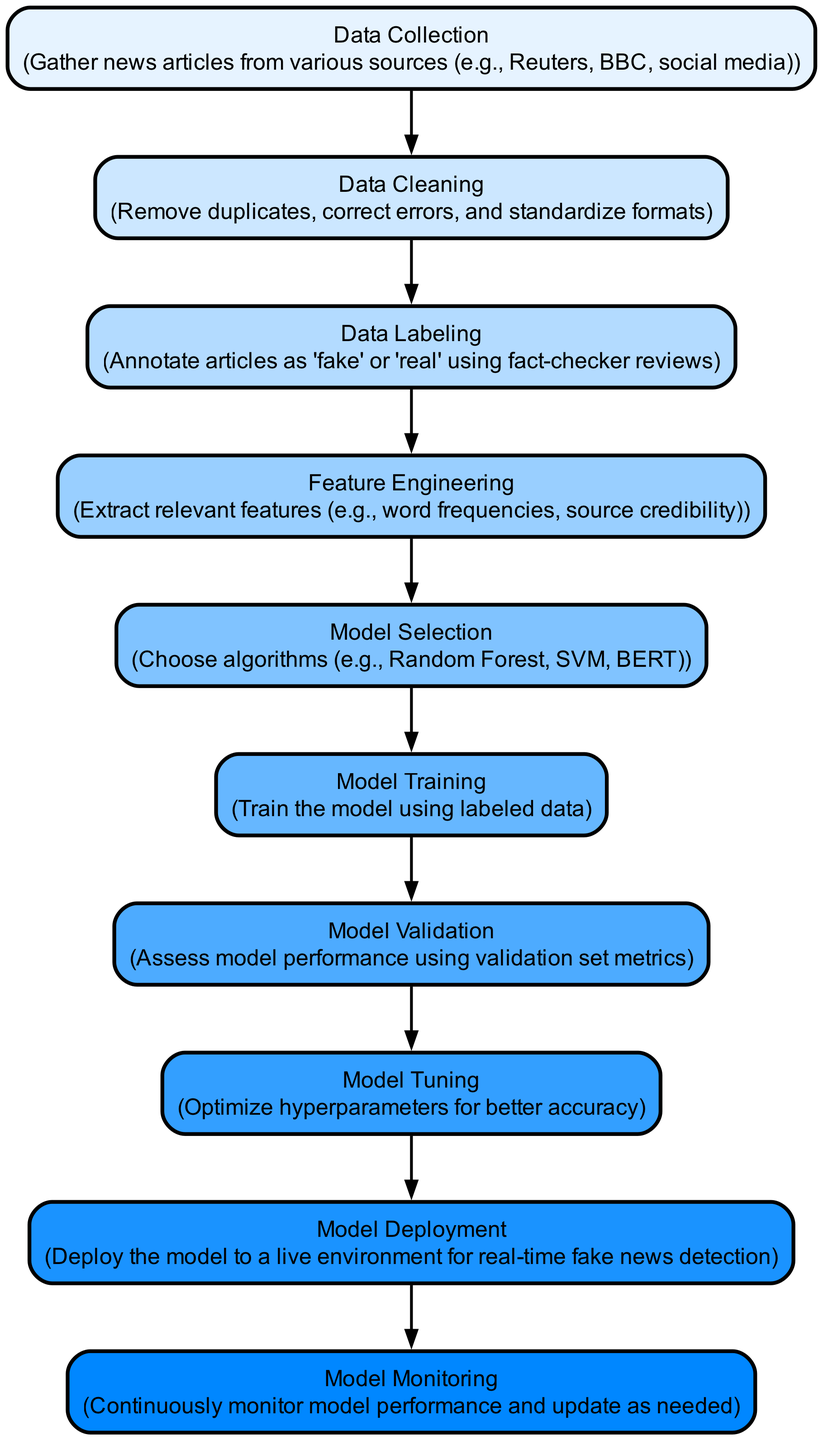What is the first step in the machine learning lifecycle? The first step in the lifecycle is "Data Collection," which involves gathering news articles from various sources. This can be identified as it is the starting node in the diagram.
Answer: Data Collection How many nodes are there in the diagram? By counting each distinct step from data collection to model monitoring, you can see there are 10 nodes in total.
Answer: 10 What is the label given to the node after data cleaning? The node immediately following "Data Cleaning" is labeled "Data Labeling." This can be traced by following the edge that connects these two nodes in the diagram.
Answer: Data Labeling What activity occurs just before model deployment? "Model Tuning" takes place just before "Model Deployment." This is determined by following the directed edge from model tuning to model deployment.
Answer: Model Tuning Which phase involves assessing model performance? The phase that involves assessing model performance is "Model Validation." This is indicated by the label of the corresponding node in the diagram.
Answer: Model Validation How many edges are in the diagram? The total number of edges in the diagram can be found by counting the connections between nodes, which amounts to 9 edges.
Answer: 9 What is the last step in the model lifecycle? The last step in the lifecycle is "Model Monitoring." This is the final node that follows "Model Deployment" in the flow of the diagram.
Answer: Model Monitoring Which phase includes extracting relevant features? "Feature Engineering" is the phase that involves extracting relevant features like word frequencies and source credibility. This is clearly marked in the diagram as a key step.
Answer: Feature Engineering What is necessary before model training can occur? "Model Selection" is necessary before "Model Training" can occur. It is the prerequisite step indicated in the diagram by the edge leading from model selection to model training.
Answer: Model Selection 